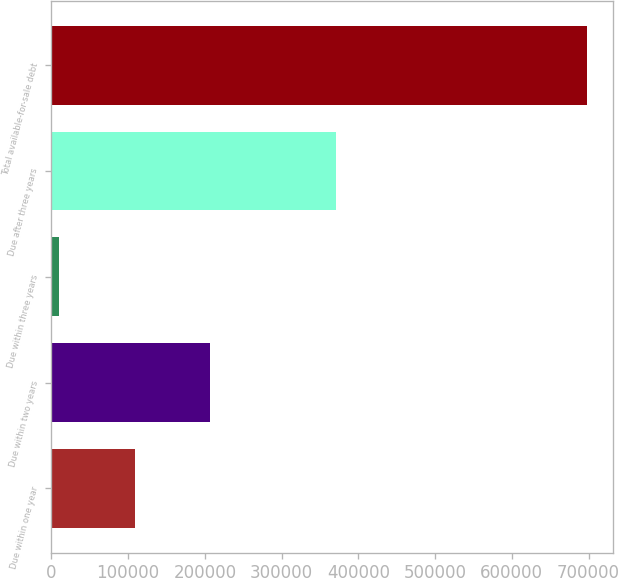Convert chart. <chart><loc_0><loc_0><loc_500><loc_500><bar_chart><fcel>Due within one year<fcel>Due within two years<fcel>Due within three years<fcel>Due after three years<fcel>Total available-for-sale debt<nl><fcel>108753<fcel>207157<fcel>10379<fcel>371111<fcel>697400<nl></chart> 